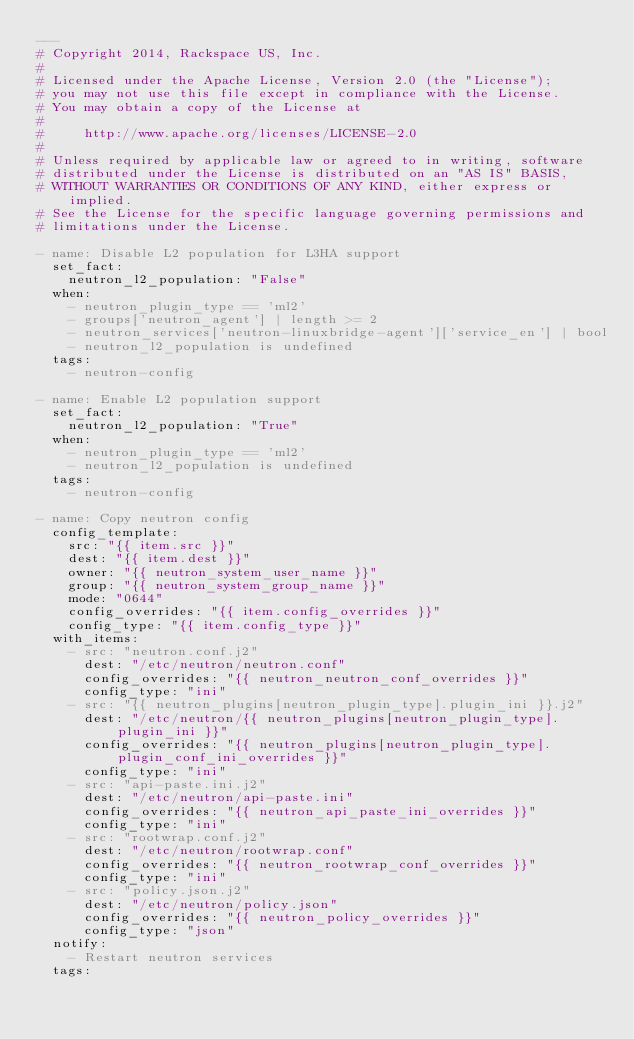Convert code to text. <code><loc_0><loc_0><loc_500><loc_500><_YAML_>---
# Copyright 2014, Rackspace US, Inc.
#
# Licensed under the Apache License, Version 2.0 (the "License");
# you may not use this file except in compliance with the License.
# You may obtain a copy of the License at
#
#     http://www.apache.org/licenses/LICENSE-2.0
#
# Unless required by applicable law or agreed to in writing, software
# distributed under the License is distributed on an "AS IS" BASIS,
# WITHOUT WARRANTIES OR CONDITIONS OF ANY KIND, either express or implied.
# See the License for the specific language governing permissions and
# limitations under the License.

- name: Disable L2 population for L3HA support
  set_fact:
    neutron_l2_population: "False"
  when:
    - neutron_plugin_type == 'ml2'
    - groups['neutron_agent'] | length >= 2
    - neutron_services['neutron-linuxbridge-agent']['service_en'] | bool
    - neutron_l2_population is undefined
  tags:
    - neutron-config

- name: Enable L2 population support
  set_fact:
    neutron_l2_population: "True"
  when:
    - neutron_plugin_type == 'ml2'
    - neutron_l2_population is undefined
  tags:
    - neutron-config

- name: Copy neutron config
  config_template:
    src: "{{ item.src }}"
    dest: "{{ item.dest }}"
    owner: "{{ neutron_system_user_name }}"
    group: "{{ neutron_system_group_name }}"
    mode: "0644"
    config_overrides: "{{ item.config_overrides }}"
    config_type: "{{ item.config_type }}"
  with_items:
    - src: "neutron.conf.j2"
      dest: "/etc/neutron/neutron.conf"
      config_overrides: "{{ neutron_neutron_conf_overrides }}"
      config_type: "ini"
    - src: "{{ neutron_plugins[neutron_plugin_type].plugin_ini }}.j2"
      dest: "/etc/neutron/{{ neutron_plugins[neutron_plugin_type].plugin_ini }}"
      config_overrides: "{{ neutron_plugins[neutron_plugin_type].plugin_conf_ini_overrides }}"
      config_type: "ini"
    - src: "api-paste.ini.j2"
      dest: "/etc/neutron/api-paste.ini"
      config_overrides: "{{ neutron_api_paste_ini_overrides }}"
      config_type: "ini"
    - src: "rootwrap.conf.j2"
      dest: "/etc/neutron/rootwrap.conf"
      config_overrides: "{{ neutron_rootwrap_conf_overrides }}"
      config_type: "ini"
    - src: "policy.json.j2"
      dest: "/etc/neutron/policy.json"
      config_overrides: "{{ neutron_policy_overrides }}"
      config_type: "json"
  notify:
    - Restart neutron services
  tags:</code> 